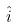Convert formula to latex. <formula><loc_0><loc_0><loc_500><loc_500>\hat { i }</formula> 